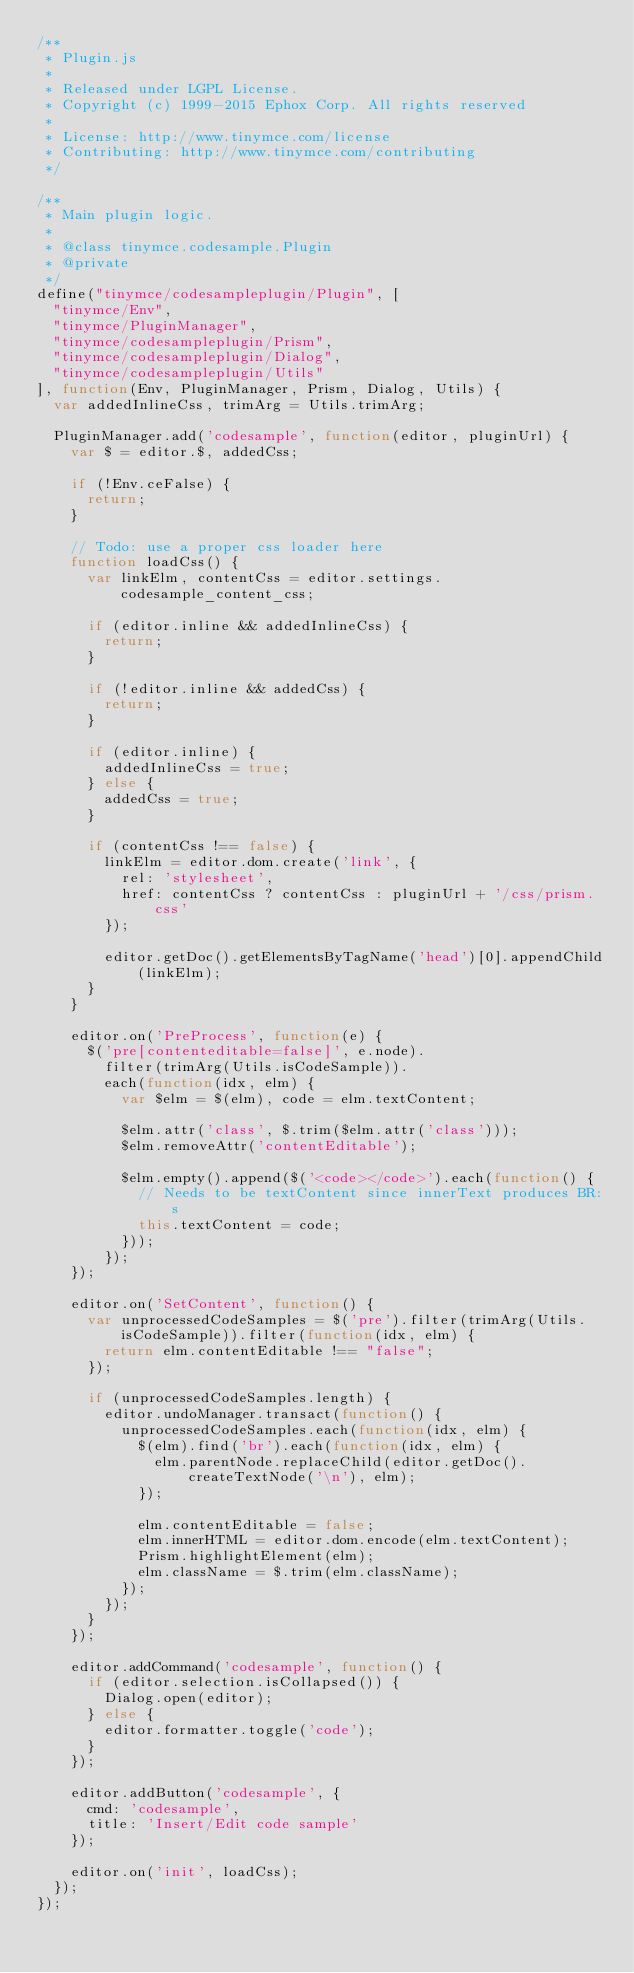<code> <loc_0><loc_0><loc_500><loc_500><_JavaScript_>/**
 * Plugin.js
 *
 * Released under LGPL License.
 * Copyright (c) 1999-2015 Ephox Corp. All rights reserved
 *
 * License: http://www.tinymce.com/license
 * Contributing: http://www.tinymce.com/contributing
 */

/**
 * Main plugin logic.
 *
 * @class tinymce.codesample.Plugin
 * @private
 */
define("tinymce/codesampleplugin/Plugin", [
	"tinymce/Env",
	"tinymce/PluginManager",
	"tinymce/codesampleplugin/Prism",
	"tinymce/codesampleplugin/Dialog",
	"tinymce/codesampleplugin/Utils"
], function(Env, PluginManager, Prism, Dialog, Utils) {
	var addedInlineCss, trimArg = Utils.trimArg;

	PluginManager.add('codesample', function(editor, pluginUrl) {
		var $ = editor.$, addedCss;

		if (!Env.ceFalse) {
			return;
		}

		// Todo: use a proper css loader here
		function loadCss() {
			var linkElm, contentCss = editor.settings.codesample_content_css;

			if (editor.inline && addedInlineCss) {
				return;
			}

			if (!editor.inline && addedCss) {
				return;
			}

			if (editor.inline) {
				addedInlineCss = true;
			} else {
				addedCss = true;
			}

			if (contentCss !== false) {
				linkElm = editor.dom.create('link', {
					rel: 'stylesheet',
					href: contentCss ? contentCss : pluginUrl + '/css/prism.css'
				});

				editor.getDoc().getElementsByTagName('head')[0].appendChild(linkElm);
			}
		}

		editor.on('PreProcess', function(e) {
			$('pre[contenteditable=false]', e.node).
				filter(trimArg(Utils.isCodeSample)).
				each(function(idx, elm) {
					var $elm = $(elm), code = elm.textContent;

					$elm.attr('class', $.trim($elm.attr('class')));
					$elm.removeAttr('contentEditable');

					$elm.empty().append($('<code></code>').each(function() {
						// Needs to be textContent since innerText produces BR:s
						this.textContent = code;
					}));
				});
		});

		editor.on('SetContent', function() {
			var unprocessedCodeSamples = $('pre').filter(trimArg(Utils.isCodeSample)).filter(function(idx, elm) {
				return elm.contentEditable !== "false";
			});

			if (unprocessedCodeSamples.length) {
				editor.undoManager.transact(function() {
					unprocessedCodeSamples.each(function(idx, elm) {
						$(elm).find('br').each(function(idx, elm) {
							elm.parentNode.replaceChild(editor.getDoc().createTextNode('\n'), elm);
						});

						elm.contentEditable = false;
						elm.innerHTML = editor.dom.encode(elm.textContent);
						Prism.highlightElement(elm);
						elm.className = $.trim(elm.className);
					});
				});
			}
		});

		editor.addCommand('codesample', function() {
			if (editor.selection.isCollapsed()) {
				Dialog.open(editor);
			} else {
				editor.formatter.toggle('code');
			}
		});

		editor.addButton('codesample', {
			cmd: 'codesample',
			title: 'Insert/Edit code sample'
		});

		editor.on('init', loadCss);
	});
});
</code> 